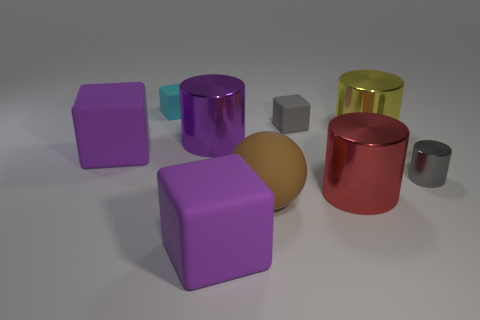Is there anything else that is the same shape as the large brown thing?
Offer a very short reply. No. There is a small cube that is the same color as the small metallic thing; what is its material?
Make the answer very short. Rubber. Are there any small blue metal things of the same shape as the yellow object?
Keep it short and to the point. No. What number of large matte things have the same shape as the tiny cyan rubber object?
Ensure brevity in your answer.  2. Does the rubber ball have the same color as the tiny shiny cylinder?
Provide a short and direct response. No. Is the number of small red rubber cylinders less than the number of big brown things?
Give a very brief answer. Yes. There is a small gray cube to the left of the red metallic cylinder; what is it made of?
Make the answer very short. Rubber. There is a brown thing that is the same size as the purple cylinder; what is its material?
Offer a terse response. Rubber. The large block behind the purple object in front of the purple block that is behind the big red cylinder is made of what material?
Keep it short and to the point. Rubber. There is a purple cube that is behind the brown ball; does it have the same size as the red thing?
Make the answer very short. Yes. 